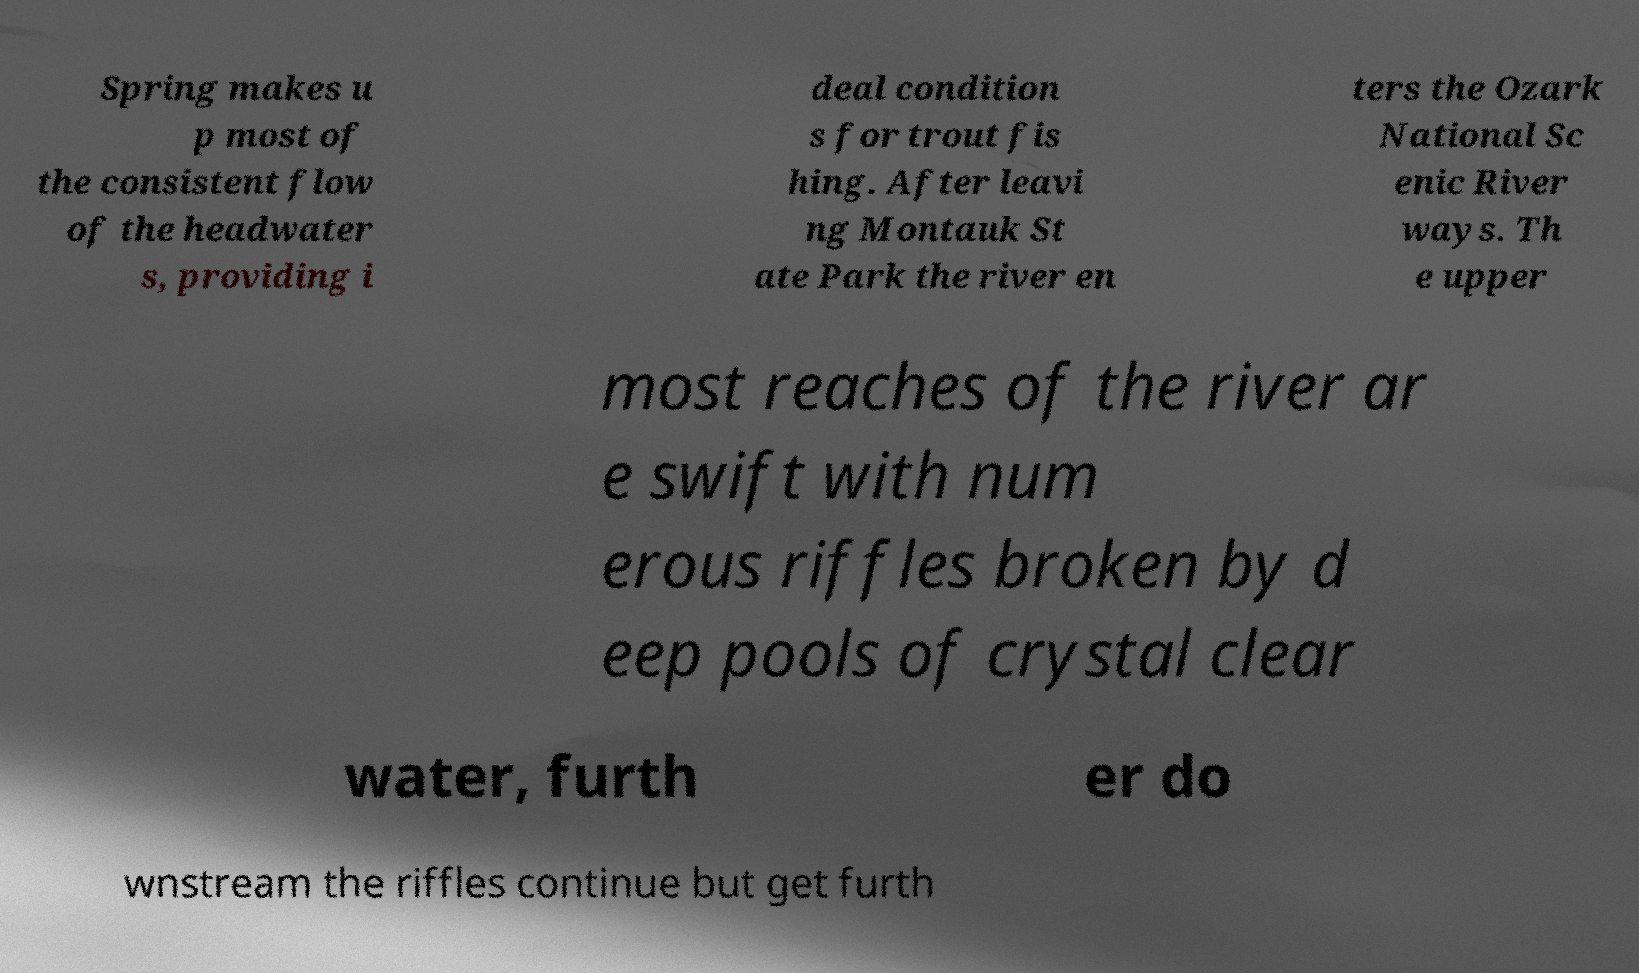Can you accurately transcribe the text from the provided image for me? Spring makes u p most of the consistent flow of the headwater s, providing i deal condition s for trout fis hing. After leavi ng Montauk St ate Park the river en ters the Ozark National Sc enic River ways. Th e upper most reaches of the river ar e swift with num erous riffles broken by d eep pools of crystal clear water, furth er do wnstream the riffles continue but get furth 